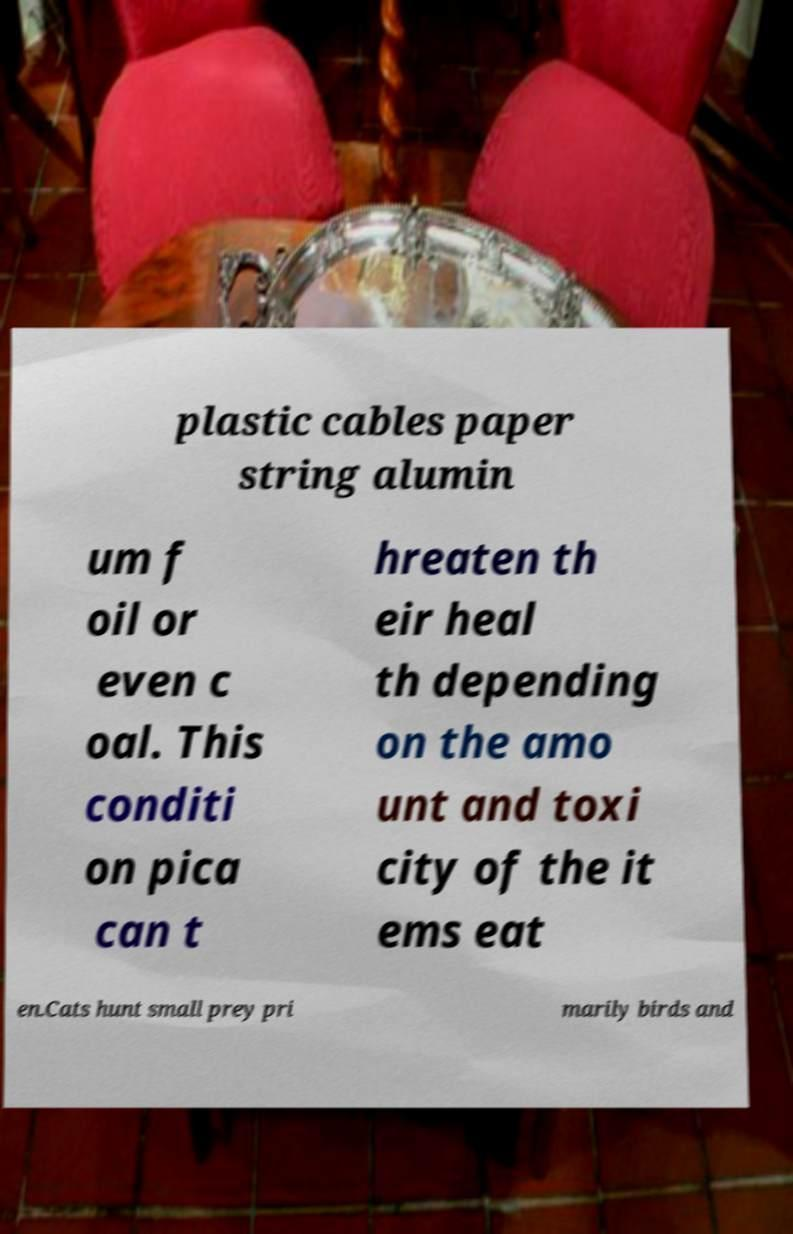For documentation purposes, I need the text within this image transcribed. Could you provide that? plastic cables paper string alumin um f oil or even c oal. This conditi on pica can t hreaten th eir heal th depending on the amo unt and toxi city of the it ems eat en.Cats hunt small prey pri marily birds and 